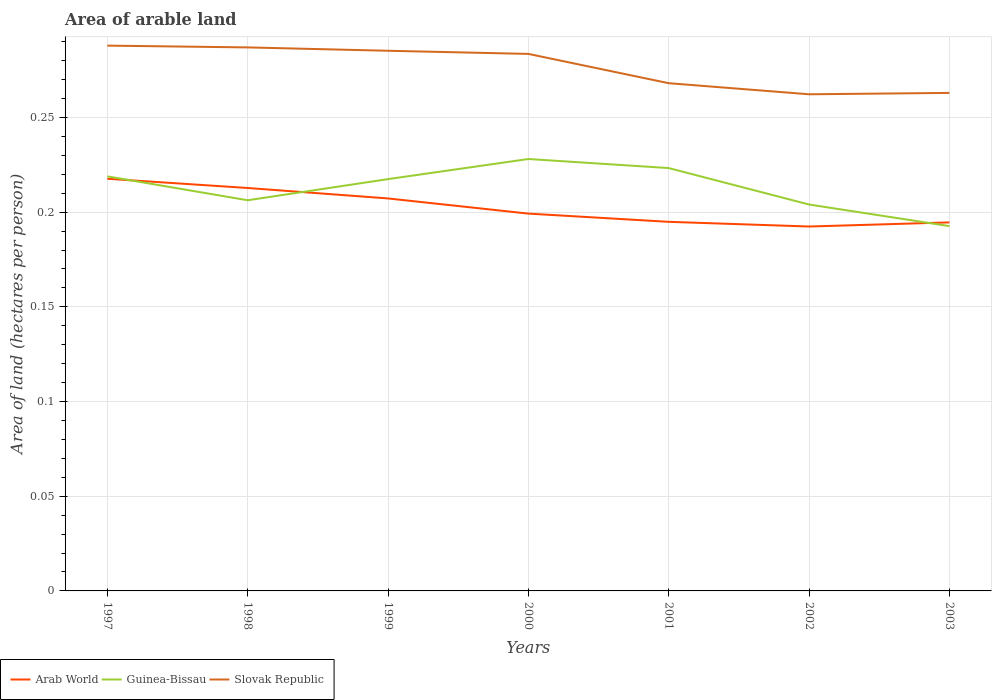Is the number of lines equal to the number of legend labels?
Offer a terse response. Yes. Across all years, what is the maximum total arable land in Slovak Republic?
Ensure brevity in your answer.  0.26. What is the total total arable land in Slovak Republic in the graph?
Make the answer very short. 0. What is the difference between the highest and the second highest total arable land in Slovak Republic?
Your answer should be compact. 0.03. What is the difference between the highest and the lowest total arable land in Slovak Republic?
Keep it short and to the point. 4. How many lines are there?
Make the answer very short. 3. What is the difference between two consecutive major ticks on the Y-axis?
Your answer should be compact. 0.05. Are the values on the major ticks of Y-axis written in scientific E-notation?
Give a very brief answer. No. Does the graph contain any zero values?
Ensure brevity in your answer.  No. Does the graph contain grids?
Your response must be concise. Yes. Where does the legend appear in the graph?
Your answer should be very brief. Bottom left. How are the legend labels stacked?
Provide a short and direct response. Horizontal. What is the title of the graph?
Give a very brief answer. Area of arable land. What is the label or title of the Y-axis?
Give a very brief answer. Area of land (hectares per person). What is the Area of land (hectares per person) of Arab World in 1997?
Your response must be concise. 0.22. What is the Area of land (hectares per person) in Guinea-Bissau in 1997?
Your answer should be very brief. 0.22. What is the Area of land (hectares per person) in Slovak Republic in 1997?
Offer a very short reply. 0.29. What is the Area of land (hectares per person) in Arab World in 1998?
Your response must be concise. 0.21. What is the Area of land (hectares per person) in Guinea-Bissau in 1998?
Provide a succinct answer. 0.21. What is the Area of land (hectares per person) of Slovak Republic in 1998?
Provide a succinct answer. 0.29. What is the Area of land (hectares per person) in Arab World in 1999?
Offer a very short reply. 0.21. What is the Area of land (hectares per person) of Guinea-Bissau in 1999?
Ensure brevity in your answer.  0.22. What is the Area of land (hectares per person) of Slovak Republic in 1999?
Your answer should be very brief. 0.29. What is the Area of land (hectares per person) of Arab World in 2000?
Keep it short and to the point. 0.2. What is the Area of land (hectares per person) of Guinea-Bissau in 2000?
Ensure brevity in your answer.  0.23. What is the Area of land (hectares per person) in Slovak Republic in 2000?
Provide a succinct answer. 0.28. What is the Area of land (hectares per person) of Arab World in 2001?
Provide a succinct answer. 0.19. What is the Area of land (hectares per person) of Guinea-Bissau in 2001?
Offer a very short reply. 0.22. What is the Area of land (hectares per person) in Slovak Republic in 2001?
Make the answer very short. 0.27. What is the Area of land (hectares per person) in Arab World in 2002?
Provide a succinct answer. 0.19. What is the Area of land (hectares per person) of Guinea-Bissau in 2002?
Offer a terse response. 0.2. What is the Area of land (hectares per person) of Slovak Republic in 2002?
Provide a short and direct response. 0.26. What is the Area of land (hectares per person) of Arab World in 2003?
Offer a very short reply. 0.19. What is the Area of land (hectares per person) of Guinea-Bissau in 2003?
Your answer should be compact. 0.19. What is the Area of land (hectares per person) of Slovak Republic in 2003?
Give a very brief answer. 0.26. Across all years, what is the maximum Area of land (hectares per person) in Arab World?
Give a very brief answer. 0.22. Across all years, what is the maximum Area of land (hectares per person) in Guinea-Bissau?
Ensure brevity in your answer.  0.23. Across all years, what is the maximum Area of land (hectares per person) of Slovak Republic?
Offer a very short reply. 0.29. Across all years, what is the minimum Area of land (hectares per person) of Arab World?
Your response must be concise. 0.19. Across all years, what is the minimum Area of land (hectares per person) of Guinea-Bissau?
Offer a terse response. 0.19. Across all years, what is the minimum Area of land (hectares per person) in Slovak Republic?
Your answer should be very brief. 0.26. What is the total Area of land (hectares per person) of Arab World in the graph?
Your answer should be compact. 1.42. What is the total Area of land (hectares per person) in Guinea-Bissau in the graph?
Provide a short and direct response. 1.49. What is the total Area of land (hectares per person) in Slovak Republic in the graph?
Make the answer very short. 1.94. What is the difference between the Area of land (hectares per person) of Arab World in 1997 and that in 1998?
Keep it short and to the point. 0. What is the difference between the Area of land (hectares per person) of Guinea-Bissau in 1997 and that in 1998?
Provide a short and direct response. 0.01. What is the difference between the Area of land (hectares per person) of Slovak Republic in 1997 and that in 1998?
Offer a terse response. 0. What is the difference between the Area of land (hectares per person) in Arab World in 1997 and that in 1999?
Offer a very short reply. 0.01. What is the difference between the Area of land (hectares per person) of Guinea-Bissau in 1997 and that in 1999?
Make the answer very short. 0. What is the difference between the Area of land (hectares per person) of Slovak Republic in 1997 and that in 1999?
Make the answer very short. 0. What is the difference between the Area of land (hectares per person) of Arab World in 1997 and that in 2000?
Offer a terse response. 0.02. What is the difference between the Area of land (hectares per person) in Guinea-Bissau in 1997 and that in 2000?
Keep it short and to the point. -0.01. What is the difference between the Area of land (hectares per person) in Slovak Republic in 1997 and that in 2000?
Your answer should be very brief. 0. What is the difference between the Area of land (hectares per person) in Arab World in 1997 and that in 2001?
Keep it short and to the point. 0.02. What is the difference between the Area of land (hectares per person) in Guinea-Bissau in 1997 and that in 2001?
Offer a terse response. -0. What is the difference between the Area of land (hectares per person) of Slovak Republic in 1997 and that in 2001?
Keep it short and to the point. 0.02. What is the difference between the Area of land (hectares per person) in Arab World in 1997 and that in 2002?
Your response must be concise. 0.03. What is the difference between the Area of land (hectares per person) of Guinea-Bissau in 1997 and that in 2002?
Offer a terse response. 0.01. What is the difference between the Area of land (hectares per person) in Slovak Republic in 1997 and that in 2002?
Provide a short and direct response. 0.03. What is the difference between the Area of land (hectares per person) of Arab World in 1997 and that in 2003?
Keep it short and to the point. 0.02. What is the difference between the Area of land (hectares per person) in Guinea-Bissau in 1997 and that in 2003?
Your response must be concise. 0.03. What is the difference between the Area of land (hectares per person) in Slovak Republic in 1997 and that in 2003?
Offer a terse response. 0.03. What is the difference between the Area of land (hectares per person) in Arab World in 1998 and that in 1999?
Provide a succinct answer. 0.01. What is the difference between the Area of land (hectares per person) in Guinea-Bissau in 1998 and that in 1999?
Provide a succinct answer. -0.01. What is the difference between the Area of land (hectares per person) in Slovak Republic in 1998 and that in 1999?
Provide a short and direct response. 0. What is the difference between the Area of land (hectares per person) in Arab World in 1998 and that in 2000?
Your answer should be very brief. 0.01. What is the difference between the Area of land (hectares per person) in Guinea-Bissau in 1998 and that in 2000?
Your response must be concise. -0.02. What is the difference between the Area of land (hectares per person) of Slovak Republic in 1998 and that in 2000?
Provide a succinct answer. 0. What is the difference between the Area of land (hectares per person) in Arab World in 1998 and that in 2001?
Provide a succinct answer. 0.02. What is the difference between the Area of land (hectares per person) in Guinea-Bissau in 1998 and that in 2001?
Provide a short and direct response. -0.02. What is the difference between the Area of land (hectares per person) of Slovak Republic in 1998 and that in 2001?
Keep it short and to the point. 0.02. What is the difference between the Area of land (hectares per person) in Arab World in 1998 and that in 2002?
Your answer should be very brief. 0.02. What is the difference between the Area of land (hectares per person) of Guinea-Bissau in 1998 and that in 2002?
Offer a terse response. 0. What is the difference between the Area of land (hectares per person) of Slovak Republic in 1998 and that in 2002?
Make the answer very short. 0.02. What is the difference between the Area of land (hectares per person) of Arab World in 1998 and that in 2003?
Your response must be concise. 0.02. What is the difference between the Area of land (hectares per person) in Guinea-Bissau in 1998 and that in 2003?
Give a very brief answer. 0.01. What is the difference between the Area of land (hectares per person) of Slovak Republic in 1998 and that in 2003?
Offer a very short reply. 0.02. What is the difference between the Area of land (hectares per person) in Arab World in 1999 and that in 2000?
Provide a succinct answer. 0.01. What is the difference between the Area of land (hectares per person) in Guinea-Bissau in 1999 and that in 2000?
Your response must be concise. -0.01. What is the difference between the Area of land (hectares per person) of Slovak Republic in 1999 and that in 2000?
Provide a succinct answer. 0. What is the difference between the Area of land (hectares per person) of Arab World in 1999 and that in 2001?
Give a very brief answer. 0.01. What is the difference between the Area of land (hectares per person) of Guinea-Bissau in 1999 and that in 2001?
Your answer should be compact. -0.01. What is the difference between the Area of land (hectares per person) of Slovak Republic in 1999 and that in 2001?
Provide a short and direct response. 0.02. What is the difference between the Area of land (hectares per person) in Arab World in 1999 and that in 2002?
Offer a terse response. 0.01. What is the difference between the Area of land (hectares per person) in Guinea-Bissau in 1999 and that in 2002?
Provide a short and direct response. 0.01. What is the difference between the Area of land (hectares per person) of Slovak Republic in 1999 and that in 2002?
Make the answer very short. 0.02. What is the difference between the Area of land (hectares per person) of Arab World in 1999 and that in 2003?
Ensure brevity in your answer.  0.01. What is the difference between the Area of land (hectares per person) of Guinea-Bissau in 1999 and that in 2003?
Give a very brief answer. 0.02. What is the difference between the Area of land (hectares per person) of Slovak Republic in 1999 and that in 2003?
Keep it short and to the point. 0.02. What is the difference between the Area of land (hectares per person) in Arab World in 2000 and that in 2001?
Provide a succinct answer. 0. What is the difference between the Area of land (hectares per person) of Guinea-Bissau in 2000 and that in 2001?
Your answer should be very brief. 0. What is the difference between the Area of land (hectares per person) of Slovak Republic in 2000 and that in 2001?
Give a very brief answer. 0.02. What is the difference between the Area of land (hectares per person) of Arab World in 2000 and that in 2002?
Provide a succinct answer. 0.01. What is the difference between the Area of land (hectares per person) of Guinea-Bissau in 2000 and that in 2002?
Provide a succinct answer. 0.02. What is the difference between the Area of land (hectares per person) in Slovak Republic in 2000 and that in 2002?
Provide a short and direct response. 0.02. What is the difference between the Area of land (hectares per person) of Arab World in 2000 and that in 2003?
Offer a terse response. 0. What is the difference between the Area of land (hectares per person) of Guinea-Bissau in 2000 and that in 2003?
Provide a short and direct response. 0.04. What is the difference between the Area of land (hectares per person) in Slovak Republic in 2000 and that in 2003?
Provide a succinct answer. 0.02. What is the difference between the Area of land (hectares per person) in Arab World in 2001 and that in 2002?
Your answer should be compact. 0. What is the difference between the Area of land (hectares per person) of Guinea-Bissau in 2001 and that in 2002?
Ensure brevity in your answer.  0.02. What is the difference between the Area of land (hectares per person) of Slovak Republic in 2001 and that in 2002?
Make the answer very short. 0.01. What is the difference between the Area of land (hectares per person) in Guinea-Bissau in 2001 and that in 2003?
Make the answer very short. 0.03. What is the difference between the Area of land (hectares per person) of Slovak Republic in 2001 and that in 2003?
Provide a succinct answer. 0.01. What is the difference between the Area of land (hectares per person) in Arab World in 2002 and that in 2003?
Keep it short and to the point. -0. What is the difference between the Area of land (hectares per person) of Guinea-Bissau in 2002 and that in 2003?
Provide a short and direct response. 0.01. What is the difference between the Area of land (hectares per person) of Slovak Republic in 2002 and that in 2003?
Offer a very short reply. -0. What is the difference between the Area of land (hectares per person) in Arab World in 1997 and the Area of land (hectares per person) in Guinea-Bissau in 1998?
Provide a succinct answer. 0.01. What is the difference between the Area of land (hectares per person) in Arab World in 1997 and the Area of land (hectares per person) in Slovak Republic in 1998?
Provide a succinct answer. -0.07. What is the difference between the Area of land (hectares per person) of Guinea-Bissau in 1997 and the Area of land (hectares per person) of Slovak Republic in 1998?
Provide a succinct answer. -0.07. What is the difference between the Area of land (hectares per person) in Arab World in 1997 and the Area of land (hectares per person) in Slovak Republic in 1999?
Give a very brief answer. -0.07. What is the difference between the Area of land (hectares per person) of Guinea-Bissau in 1997 and the Area of land (hectares per person) of Slovak Republic in 1999?
Offer a very short reply. -0.07. What is the difference between the Area of land (hectares per person) in Arab World in 1997 and the Area of land (hectares per person) in Guinea-Bissau in 2000?
Make the answer very short. -0.01. What is the difference between the Area of land (hectares per person) of Arab World in 1997 and the Area of land (hectares per person) of Slovak Republic in 2000?
Keep it short and to the point. -0.07. What is the difference between the Area of land (hectares per person) of Guinea-Bissau in 1997 and the Area of land (hectares per person) of Slovak Republic in 2000?
Make the answer very short. -0.06. What is the difference between the Area of land (hectares per person) in Arab World in 1997 and the Area of land (hectares per person) in Guinea-Bissau in 2001?
Keep it short and to the point. -0.01. What is the difference between the Area of land (hectares per person) of Arab World in 1997 and the Area of land (hectares per person) of Slovak Republic in 2001?
Offer a very short reply. -0.05. What is the difference between the Area of land (hectares per person) in Guinea-Bissau in 1997 and the Area of land (hectares per person) in Slovak Republic in 2001?
Provide a short and direct response. -0.05. What is the difference between the Area of land (hectares per person) of Arab World in 1997 and the Area of land (hectares per person) of Guinea-Bissau in 2002?
Make the answer very short. 0.01. What is the difference between the Area of land (hectares per person) of Arab World in 1997 and the Area of land (hectares per person) of Slovak Republic in 2002?
Give a very brief answer. -0.04. What is the difference between the Area of land (hectares per person) of Guinea-Bissau in 1997 and the Area of land (hectares per person) of Slovak Republic in 2002?
Offer a very short reply. -0.04. What is the difference between the Area of land (hectares per person) of Arab World in 1997 and the Area of land (hectares per person) of Guinea-Bissau in 2003?
Give a very brief answer. 0.03. What is the difference between the Area of land (hectares per person) in Arab World in 1997 and the Area of land (hectares per person) in Slovak Republic in 2003?
Provide a short and direct response. -0.05. What is the difference between the Area of land (hectares per person) of Guinea-Bissau in 1997 and the Area of land (hectares per person) of Slovak Republic in 2003?
Your response must be concise. -0.04. What is the difference between the Area of land (hectares per person) in Arab World in 1998 and the Area of land (hectares per person) in Guinea-Bissau in 1999?
Keep it short and to the point. -0. What is the difference between the Area of land (hectares per person) in Arab World in 1998 and the Area of land (hectares per person) in Slovak Republic in 1999?
Ensure brevity in your answer.  -0.07. What is the difference between the Area of land (hectares per person) of Guinea-Bissau in 1998 and the Area of land (hectares per person) of Slovak Republic in 1999?
Your answer should be very brief. -0.08. What is the difference between the Area of land (hectares per person) of Arab World in 1998 and the Area of land (hectares per person) of Guinea-Bissau in 2000?
Provide a short and direct response. -0.02. What is the difference between the Area of land (hectares per person) of Arab World in 1998 and the Area of land (hectares per person) of Slovak Republic in 2000?
Offer a very short reply. -0.07. What is the difference between the Area of land (hectares per person) in Guinea-Bissau in 1998 and the Area of land (hectares per person) in Slovak Republic in 2000?
Ensure brevity in your answer.  -0.08. What is the difference between the Area of land (hectares per person) of Arab World in 1998 and the Area of land (hectares per person) of Guinea-Bissau in 2001?
Give a very brief answer. -0.01. What is the difference between the Area of land (hectares per person) in Arab World in 1998 and the Area of land (hectares per person) in Slovak Republic in 2001?
Offer a terse response. -0.06. What is the difference between the Area of land (hectares per person) in Guinea-Bissau in 1998 and the Area of land (hectares per person) in Slovak Republic in 2001?
Give a very brief answer. -0.06. What is the difference between the Area of land (hectares per person) of Arab World in 1998 and the Area of land (hectares per person) of Guinea-Bissau in 2002?
Your answer should be very brief. 0.01. What is the difference between the Area of land (hectares per person) in Arab World in 1998 and the Area of land (hectares per person) in Slovak Republic in 2002?
Provide a succinct answer. -0.05. What is the difference between the Area of land (hectares per person) in Guinea-Bissau in 1998 and the Area of land (hectares per person) in Slovak Republic in 2002?
Offer a very short reply. -0.06. What is the difference between the Area of land (hectares per person) of Arab World in 1998 and the Area of land (hectares per person) of Guinea-Bissau in 2003?
Offer a very short reply. 0.02. What is the difference between the Area of land (hectares per person) of Arab World in 1998 and the Area of land (hectares per person) of Slovak Republic in 2003?
Keep it short and to the point. -0.05. What is the difference between the Area of land (hectares per person) of Guinea-Bissau in 1998 and the Area of land (hectares per person) of Slovak Republic in 2003?
Your response must be concise. -0.06. What is the difference between the Area of land (hectares per person) of Arab World in 1999 and the Area of land (hectares per person) of Guinea-Bissau in 2000?
Make the answer very short. -0.02. What is the difference between the Area of land (hectares per person) in Arab World in 1999 and the Area of land (hectares per person) in Slovak Republic in 2000?
Your answer should be compact. -0.08. What is the difference between the Area of land (hectares per person) of Guinea-Bissau in 1999 and the Area of land (hectares per person) of Slovak Republic in 2000?
Your answer should be very brief. -0.07. What is the difference between the Area of land (hectares per person) of Arab World in 1999 and the Area of land (hectares per person) of Guinea-Bissau in 2001?
Make the answer very short. -0.02. What is the difference between the Area of land (hectares per person) of Arab World in 1999 and the Area of land (hectares per person) of Slovak Republic in 2001?
Offer a terse response. -0.06. What is the difference between the Area of land (hectares per person) in Guinea-Bissau in 1999 and the Area of land (hectares per person) in Slovak Republic in 2001?
Provide a succinct answer. -0.05. What is the difference between the Area of land (hectares per person) in Arab World in 1999 and the Area of land (hectares per person) in Guinea-Bissau in 2002?
Your answer should be compact. 0. What is the difference between the Area of land (hectares per person) in Arab World in 1999 and the Area of land (hectares per person) in Slovak Republic in 2002?
Offer a terse response. -0.06. What is the difference between the Area of land (hectares per person) in Guinea-Bissau in 1999 and the Area of land (hectares per person) in Slovak Republic in 2002?
Make the answer very short. -0.04. What is the difference between the Area of land (hectares per person) in Arab World in 1999 and the Area of land (hectares per person) in Guinea-Bissau in 2003?
Make the answer very short. 0.01. What is the difference between the Area of land (hectares per person) of Arab World in 1999 and the Area of land (hectares per person) of Slovak Republic in 2003?
Ensure brevity in your answer.  -0.06. What is the difference between the Area of land (hectares per person) of Guinea-Bissau in 1999 and the Area of land (hectares per person) of Slovak Republic in 2003?
Your answer should be compact. -0.05. What is the difference between the Area of land (hectares per person) of Arab World in 2000 and the Area of land (hectares per person) of Guinea-Bissau in 2001?
Offer a terse response. -0.02. What is the difference between the Area of land (hectares per person) of Arab World in 2000 and the Area of land (hectares per person) of Slovak Republic in 2001?
Your answer should be very brief. -0.07. What is the difference between the Area of land (hectares per person) of Guinea-Bissau in 2000 and the Area of land (hectares per person) of Slovak Republic in 2001?
Provide a short and direct response. -0.04. What is the difference between the Area of land (hectares per person) in Arab World in 2000 and the Area of land (hectares per person) in Guinea-Bissau in 2002?
Provide a succinct answer. -0. What is the difference between the Area of land (hectares per person) in Arab World in 2000 and the Area of land (hectares per person) in Slovak Republic in 2002?
Provide a short and direct response. -0.06. What is the difference between the Area of land (hectares per person) in Guinea-Bissau in 2000 and the Area of land (hectares per person) in Slovak Republic in 2002?
Ensure brevity in your answer.  -0.03. What is the difference between the Area of land (hectares per person) in Arab World in 2000 and the Area of land (hectares per person) in Guinea-Bissau in 2003?
Offer a very short reply. 0.01. What is the difference between the Area of land (hectares per person) of Arab World in 2000 and the Area of land (hectares per person) of Slovak Republic in 2003?
Give a very brief answer. -0.06. What is the difference between the Area of land (hectares per person) of Guinea-Bissau in 2000 and the Area of land (hectares per person) of Slovak Republic in 2003?
Provide a succinct answer. -0.03. What is the difference between the Area of land (hectares per person) in Arab World in 2001 and the Area of land (hectares per person) in Guinea-Bissau in 2002?
Your answer should be compact. -0.01. What is the difference between the Area of land (hectares per person) of Arab World in 2001 and the Area of land (hectares per person) of Slovak Republic in 2002?
Your answer should be very brief. -0.07. What is the difference between the Area of land (hectares per person) in Guinea-Bissau in 2001 and the Area of land (hectares per person) in Slovak Republic in 2002?
Your response must be concise. -0.04. What is the difference between the Area of land (hectares per person) in Arab World in 2001 and the Area of land (hectares per person) in Guinea-Bissau in 2003?
Offer a terse response. 0. What is the difference between the Area of land (hectares per person) of Arab World in 2001 and the Area of land (hectares per person) of Slovak Republic in 2003?
Keep it short and to the point. -0.07. What is the difference between the Area of land (hectares per person) of Guinea-Bissau in 2001 and the Area of land (hectares per person) of Slovak Republic in 2003?
Ensure brevity in your answer.  -0.04. What is the difference between the Area of land (hectares per person) in Arab World in 2002 and the Area of land (hectares per person) in Guinea-Bissau in 2003?
Offer a very short reply. -0. What is the difference between the Area of land (hectares per person) of Arab World in 2002 and the Area of land (hectares per person) of Slovak Republic in 2003?
Offer a very short reply. -0.07. What is the difference between the Area of land (hectares per person) in Guinea-Bissau in 2002 and the Area of land (hectares per person) in Slovak Republic in 2003?
Provide a succinct answer. -0.06. What is the average Area of land (hectares per person) of Arab World per year?
Your answer should be very brief. 0.2. What is the average Area of land (hectares per person) in Guinea-Bissau per year?
Ensure brevity in your answer.  0.21. What is the average Area of land (hectares per person) in Slovak Republic per year?
Provide a succinct answer. 0.28. In the year 1997, what is the difference between the Area of land (hectares per person) of Arab World and Area of land (hectares per person) of Guinea-Bissau?
Give a very brief answer. -0. In the year 1997, what is the difference between the Area of land (hectares per person) in Arab World and Area of land (hectares per person) in Slovak Republic?
Your answer should be compact. -0.07. In the year 1997, what is the difference between the Area of land (hectares per person) of Guinea-Bissau and Area of land (hectares per person) of Slovak Republic?
Your answer should be very brief. -0.07. In the year 1998, what is the difference between the Area of land (hectares per person) in Arab World and Area of land (hectares per person) in Guinea-Bissau?
Your answer should be compact. 0.01. In the year 1998, what is the difference between the Area of land (hectares per person) of Arab World and Area of land (hectares per person) of Slovak Republic?
Offer a terse response. -0.07. In the year 1998, what is the difference between the Area of land (hectares per person) of Guinea-Bissau and Area of land (hectares per person) of Slovak Republic?
Keep it short and to the point. -0.08. In the year 1999, what is the difference between the Area of land (hectares per person) in Arab World and Area of land (hectares per person) in Guinea-Bissau?
Make the answer very short. -0.01. In the year 1999, what is the difference between the Area of land (hectares per person) in Arab World and Area of land (hectares per person) in Slovak Republic?
Offer a terse response. -0.08. In the year 1999, what is the difference between the Area of land (hectares per person) of Guinea-Bissau and Area of land (hectares per person) of Slovak Republic?
Give a very brief answer. -0.07. In the year 2000, what is the difference between the Area of land (hectares per person) of Arab World and Area of land (hectares per person) of Guinea-Bissau?
Your response must be concise. -0.03. In the year 2000, what is the difference between the Area of land (hectares per person) in Arab World and Area of land (hectares per person) in Slovak Republic?
Provide a succinct answer. -0.08. In the year 2000, what is the difference between the Area of land (hectares per person) of Guinea-Bissau and Area of land (hectares per person) of Slovak Republic?
Keep it short and to the point. -0.06. In the year 2001, what is the difference between the Area of land (hectares per person) in Arab World and Area of land (hectares per person) in Guinea-Bissau?
Provide a short and direct response. -0.03. In the year 2001, what is the difference between the Area of land (hectares per person) of Arab World and Area of land (hectares per person) of Slovak Republic?
Provide a succinct answer. -0.07. In the year 2001, what is the difference between the Area of land (hectares per person) in Guinea-Bissau and Area of land (hectares per person) in Slovak Republic?
Make the answer very short. -0.04. In the year 2002, what is the difference between the Area of land (hectares per person) of Arab World and Area of land (hectares per person) of Guinea-Bissau?
Your response must be concise. -0.01. In the year 2002, what is the difference between the Area of land (hectares per person) in Arab World and Area of land (hectares per person) in Slovak Republic?
Keep it short and to the point. -0.07. In the year 2002, what is the difference between the Area of land (hectares per person) of Guinea-Bissau and Area of land (hectares per person) of Slovak Republic?
Provide a short and direct response. -0.06. In the year 2003, what is the difference between the Area of land (hectares per person) in Arab World and Area of land (hectares per person) in Guinea-Bissau?
Offer a very short reply. 0. In the year 2003, what is the difference between the Area of land (hectares per person) of Arab World and Area of land (hectares per person) of Slovak Republic?
Offer a terse response. -0.07. In the year 2003, what is the difference between the Area of land (hectares per person) in Guinea-Bissau and Area of land (hectares per person) in Slovak Republic?
Make the answer very short. -0.07. What is the ratio of the Area of land (hectares per person) in Guinea-Bissau in 1997 to that in 1998?
Make the answer very short. 1.06. What is the ratio of the Area of land (hectares per person) of Slovak Republic in 1997 to that in 1998?
Your response must be concise. 1. What is the ratio of the Area of land (hectares per person) of Arab World in 1997 to that in 1999?
Give a very brief answer. 1.05. What is the ratio of the Area of land (hectares per person) of Slovak Republic in 1997 to that in 1999?
Offer a terse response. 1.01. What is the ratio of the Area of land (hectares per person) of Arab World in 1997 to that in 2000?
Make the answer very short. 1.09. What is the ratio of the Area of land (hectares per person) in Guinea-Bissau in 1997 to that in 2000?
Give a very brief answer. 0.96. What is the ratio of the Area of land (hectares per person) in Slovak Republic in 1997 to that in 2000?
Make the answer very short. 1.02. What is the ratio of the Area of land (hectares per person) of Arab World in 1997 to that in 2001?
Your response must be concise. 1.12. What is the ratio of the Area of land (hectares per person) in Guinea-Bissau in 1997 to that in 2001?
Your answer should be compact. 0.98. What is the ratio of the Area of land (hectares per person) in Slovak Republic in 1997 to that in 2001?
Your answer should be very brief. 1.07. What is the ratio of the Area of land (hectares per person) of Arab World in 1997 to that in 2002?
Offer a very short reply. 1.13. What is the ratio of the Area of land (hectares per person) of Guinea-Bissau in 1997 to that in 2002?
Provide a short and direct response. 1.07. What is the ratio of the Area of land (hectares per person) of Slovak Republic in 1997 to that in 2002?
Keep it short and to the point. 1.1. What is the ratio of the Area of land (hectares per person) in Arab World in 1997 to that in 2003?
Give a very brief answer. 1.12. What is the ratio of the Area of land (hectares per person) of Guinea-Bissau in 1997 to that in 2003?
Your response must be concise. 1.14. What is the ratio of the Area of land (hectares per person) in Slovak Republic in 1997 to that in 2003?
Provide a short and direct response. 1.09. What is the ratio of the Area of land (hectares per person) in Arab World in 1998 to that in 1999?
Provide a short and direct response. 1.03. What is the ratio of the Area of land (hectares per person) in Guinea-Bissau in 1998 to that in 1999?
Your answer should be compact. 0.95. What is the ratio of the Area of land (hectares per person) of Slovak Republic in 1998 to that in 1999?
Your response must be concise. 1.01. What is the ratio of the Area of land (hectares per person) of Arab World in 1998 to that in 2000?
Provide a succinct answer. 1.07. What is the ratio of the Area of land (hectares per person) in Guinea-Bissau in 1998 to that in 2000?
Your answer should be compact. 0.9. What is the ratio of the Area of land (hectares per person) in Slovak Republic in 1998 to that in 2000?
Keep it short and to the point. 1.01. What is the ratio of the Area of land (hectares per person) in Arab World in 1998 to that in 2001?
Your answer should be very brief. 1.09. What is the ratio of the Area of land (hectares per person) of Guinea-Bissau in 1998 to that in 2001?
Provide a succinct answer. 0.92. What is the ratio of the Area of land (hectares per person) in Slovak Republic in 1998 to that in 2001?
Keep it short and to the point. 1.07. What is the ratio of the Area of land (hectares per person) of Arab World in 1998 to that in 2002?
Your answer should be very brief. 1.11. What is the ratio of the Area of land (hectares per person) in Slovak Republic in 1998 to that in 2002?
Keep it short and to the point. 1.09. What is the ratio of the Area of land (hectares per person) of Arab World in 1998 to that in 2003?
Your response must be concise. 1.09. What is the ratio of the Area of land (hectares per person) in Guinea-Bissau in 1998 to that in 2003?
Ensure brevity in your answer.  1.07. What is the ratio of the Area of land (hectares per person) in Slovak Republic in 1998 to that in 2003?
Offer a terse response. 1.09. What is the ratio of the Area of land (hectares per person) of Arab World in 1999 to that in 2000?
Ensure brevity in your answer.  1.04. What is the ratio of the Area of land (hectares per person) in Guinea-Bissau in 1999 to that in 2000?
Give a very brief answer. 0.95. What is the ratio of the Area of land (hectares per person) of Arab World in 1999 to that in 2001?
Provide a succinct answer. 1.06. What is the ratio of the Area of land (hectares per person) in Guinea-Bissau in 1999 to that in 2001?
Provide a short and direct response. 0.97. What is the ratio of the Area of land (hectares per person) of Slovak Republic in 1999 to that in 2001?
Your response must be concise. 1.06. What is the ratio of the Area of land (hectares per person) in Arab World in 1999 to that in 2002?
Provide a succinct answer. 1.08. What is the ratio of the Area of land (hectares per person) of Guinea-Bissau in 1999 to that in 2002?
Ensure brevity in your answer.  1.07. What is the ratio of the Area of land (hectares per person) in Slovak Republic in 1999 to that in 2002?
Your answer should be very brief. 1.09. What is the ratio of the Area of land (hectares per person) of Arab World in 1999 to that in 2003?
Keep it short and to the point. 1.06. What is the ratio of the Area of land (hectares per person) in Guinea-Bissau in 1999 to that in 2003?
Your response must be concise. 1.13. What is the ratio of the Area of land (hectares per person) in Slovak Republic in 1999 to that in 2003?
Offer a very short reply. 1.08. What is the ratio of the Area of land (hectares per person) of Arab World in 2000 to that in 2001?
Offer a terse response. 1.02. What is the ratio of the Area of land (hectares per person) of Guinea-Bissau in 2000 to that in 2001?
Your answer should be compact. 1.02. What is the ratio of the Area of land (hectares per person) in Slovak Republic in 2000 to that in 2001?
Your response must be concise. 1.06. What is the ratio of the Area of land (hectares per person) in Arab World in 2000 to that in 2002?
Offer a terse response. 1.04. What is the ratio of the Area of land (hectares per person) of Guinea-Bissau in 2000 to that in 2002?
Offer a terse response. 1.12. What is the ratio of the Area of land (hectares per person) in Slovak Republic in 2000 to that in 2002?
Keep it short and to the point. 1.08. What is the ratio of the Area of land (hectares per person) in Arab World in 2000 to that in 2003?
Your response must be concise. 1.02. What is the ratio of the Area of land (hectares per person) of Guinea-Bissau in 2000 to that in 2003?
Make the answer very short. 1.18. What is the ratio of the Area of land (hectares per person) of Slovak Republic in 2000 to that in 2003?
Keep it short and to the point. 1.08. What is the ratio of the Area of land (hectares per person) of Arab World in 2001 to that in 2002?
Ensure brevity in your answer.  1.01. What is the ratio of the Area of land (hectares per person) of Guinea-Bissau in 2001 to that in 2002?
Offer a very short reply. 1.09. What is the ratio of the Area of land (hectares per person) of Slovak Republic in 2001 to that in 2002?
Your answer should be compact. 1.02. What is the ratio of the Area of land (hectares per person) of Guinea-Bissau in 2001 to that in 2003?
Make the answer very short. 1.16. What is the ratio of the Area of land (hectares per person) in Slovak Republic in 2001 to that in 2003?
Offer a very short reply. 1.02. What is the ratio of the Area of land (hectares per person) of Guinea-Bissau in 2002 to that in 2003?
Give a very brief answer. 1.06. What is the ratio of the Area of land (hectares per person) of Slovak Republic in 2002 to that in 2003?
Ensure brevity in your answer.  1. What is the difference between the highest and the second highest Area of land (hectares per person) in Arab World?
Your answer should be very brief. 0. What is the difference between the highest and the second highest Area of land (hectares per person) of Guinea-Bissau?
Your answer should be compact. 0. What is the difference between the highest and the second highest Area of land (hectares per person) in Slovak Republic?
Give a very brief answer. 0. What is the difference between the highest and the lowest Area of land (hectares per person) of Arab World?
Offer a terse response. 0.03. What is the difference between the highest and the lowest Area of land (hectares per person) in Guinea-Bissau?
Make the answer very short. 0.04. What is the difference between the highest and the lowest Area of land (hectares per person) in Slovak Republic?
Ensure brevity in your answer.  0.03. 